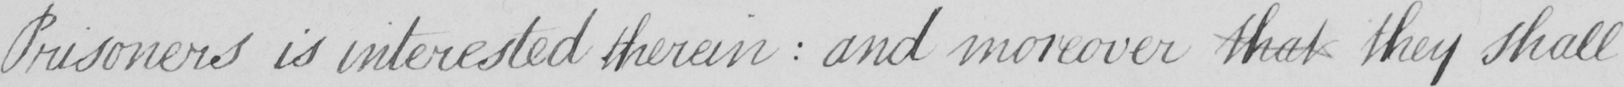What text is written in this handwritten line? Prisoners is interested therein  :  and moreover that they shall 